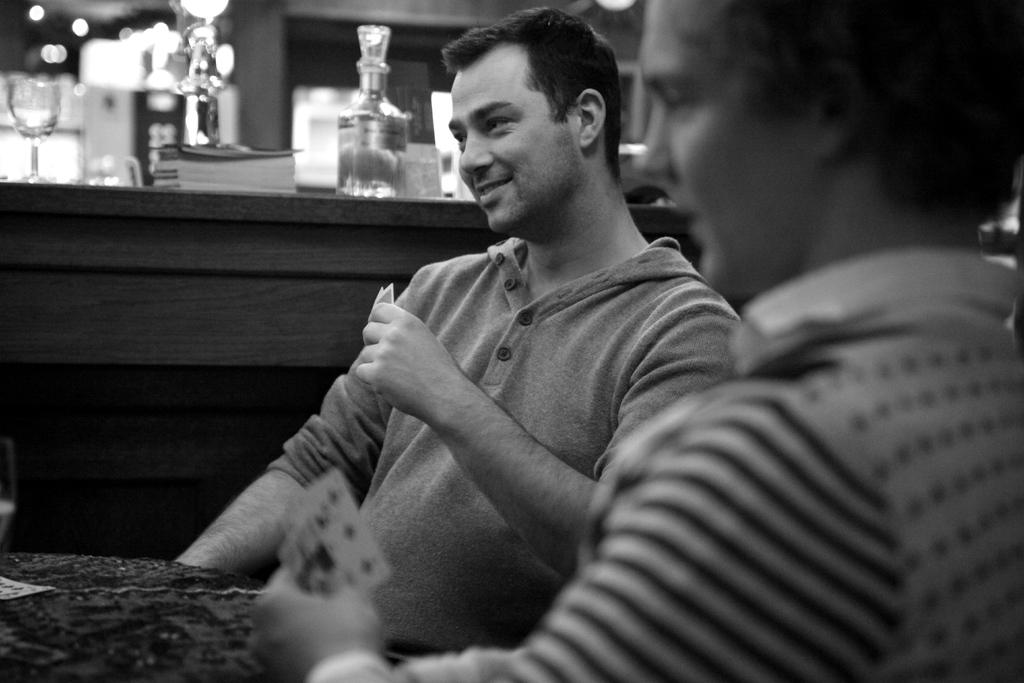What is the color scheme of the image? The image is black and white. What are the persons in the image doing? The persons are sitting and holding cards. What is on the table in the image? There is a card, a bottle, and a glass on the table. What scientific experiment is being conducted in the image? There is no scientific experiment being conducted in the image; it features persons sitting and holding cards. What actor is present in the image? There is no actor present in the image; it features persons sitting and holding cards. 